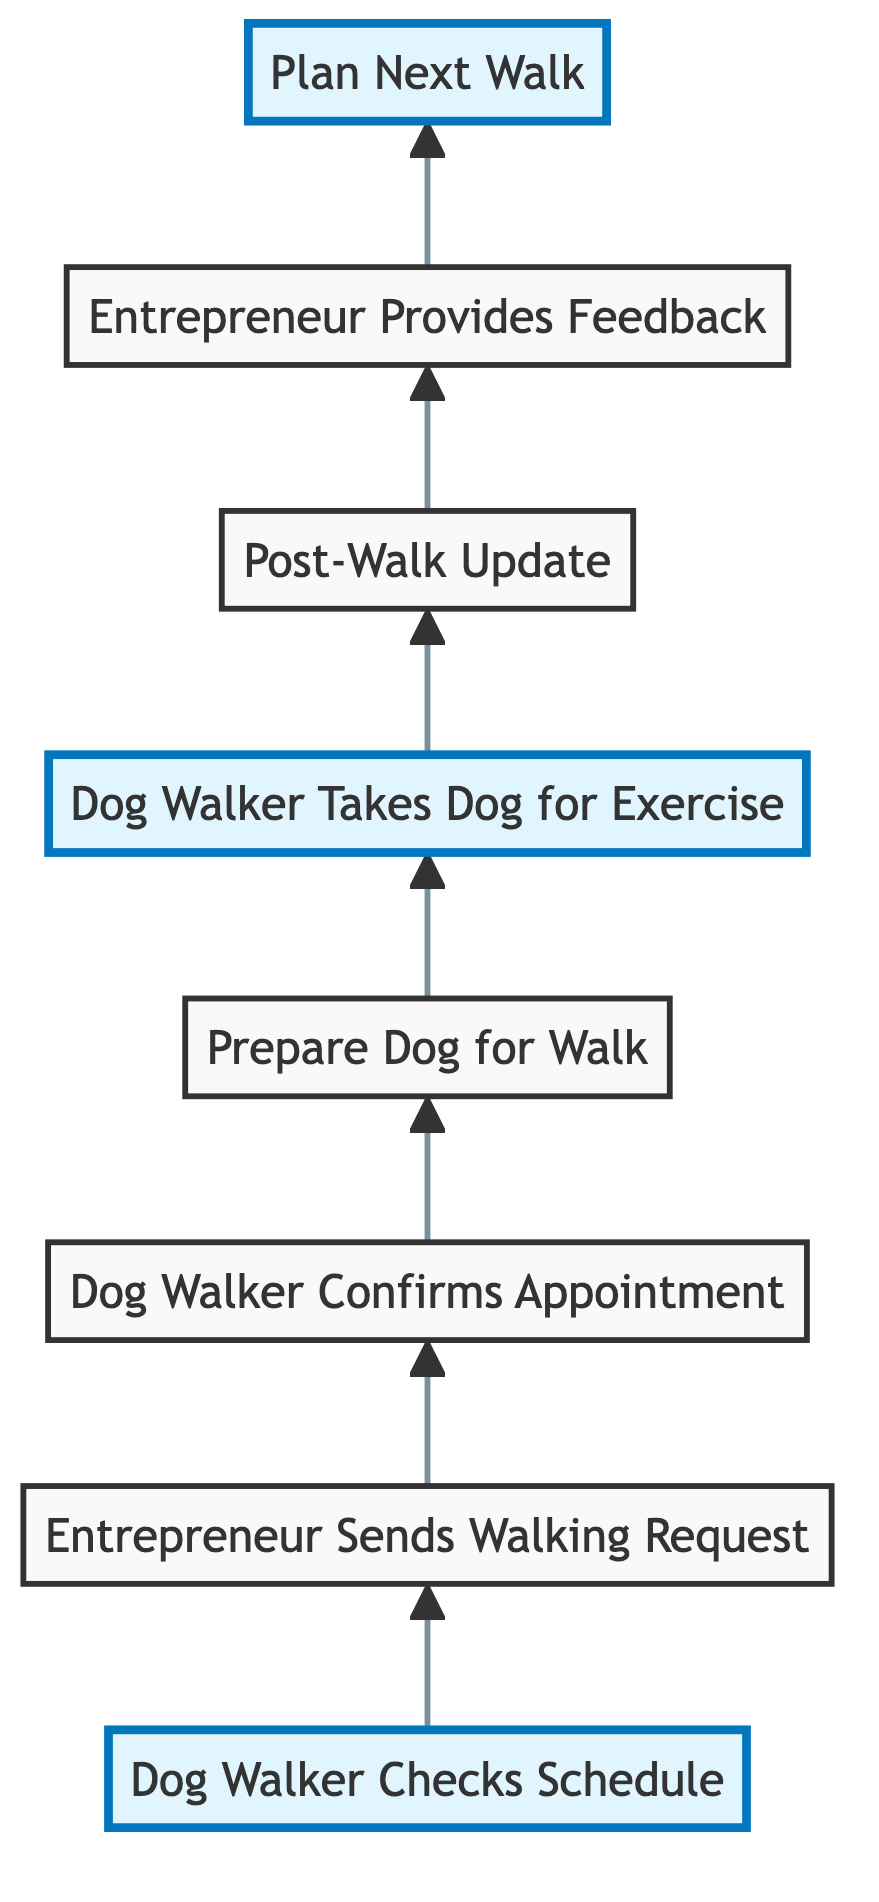What is the first step in the workflow? The first step in the workflow is represented by the node that initiates the process, which is "Dog Walker Checks Schedule."
Answer: Dog Walker Checks Schedule How many steps are there in total? By counting each individual step in the workflow from start to finish, there are a total of eight steps represented in the diagram.
Answer: Eight What does the "Post-Walk Update" entail? The "Post-Walk Update" step involves the dog walker sending a message to the entrepreneur with details about the walk, specifically involving the dog's behavior and any issues that arose.
Answer: Message about walk and dog's behavior What follows after the "Entrepreneur Provides Feedback"? The step that immediately follows "Entrepreneur Provides Feedback" in the workflow is "Plan Next Walk." This indicates that after receiving feedback, preparations for the subsequent walk are made.
Answer: Plan Next Walk What is the main action of the "Dog Walker Takes Dog for Exercise"? The main action described at this step is that the dog walker engages the dog in physical activity, which also includes playtime with other dogs.
Answer: Engages the dog in physical activity In which step does the entrepreneur send their specific preferences? The entrepreneur sends their specific preferences for walking times and other details during the step titled "Entrepreneur Sends Walking Request."
Answer: Entrepreneur Sends Walking Request What is the purpose of "Plan Next Walk"? The purpose of this step is to schedule and adapt future walking times based on the feedback received from the entrepreneur and any changes in their routine.
Answer: Schedule and adapt future walks How does the "Dog Walker Confirms Appointment" relate to the "Entrepreneur Sends Walking Request"? The relationship is sequential; the entrepreneur's sending of the walking request directly leads to the dog walker confirming the appointment, indicating a direct response to the request.
Answer: Dog Walker Confirms Appointment follows Entrepreneur Sends Walking Request What is highlighted in the diagram? The highlighted steps in the diagram are "Dog Walker Checks Schedule," "Dog Walker Takes Dog for Exercise," and "Plan Next Walk," indicating their importance in the workflow.
Answer: Dog Walker Checks Schedule, Dog Walker Takes Dog for Exercise, Plan Next Walk 